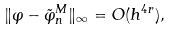Convert formula to latex. <formula><loc_0><loc_0><loc_500><loc_500>\| \varphi - \tilde { \varphi } _ { n } ^ { M } \| _ { \infty } = O ( h ^ { 4 r } ) ,</formula> 